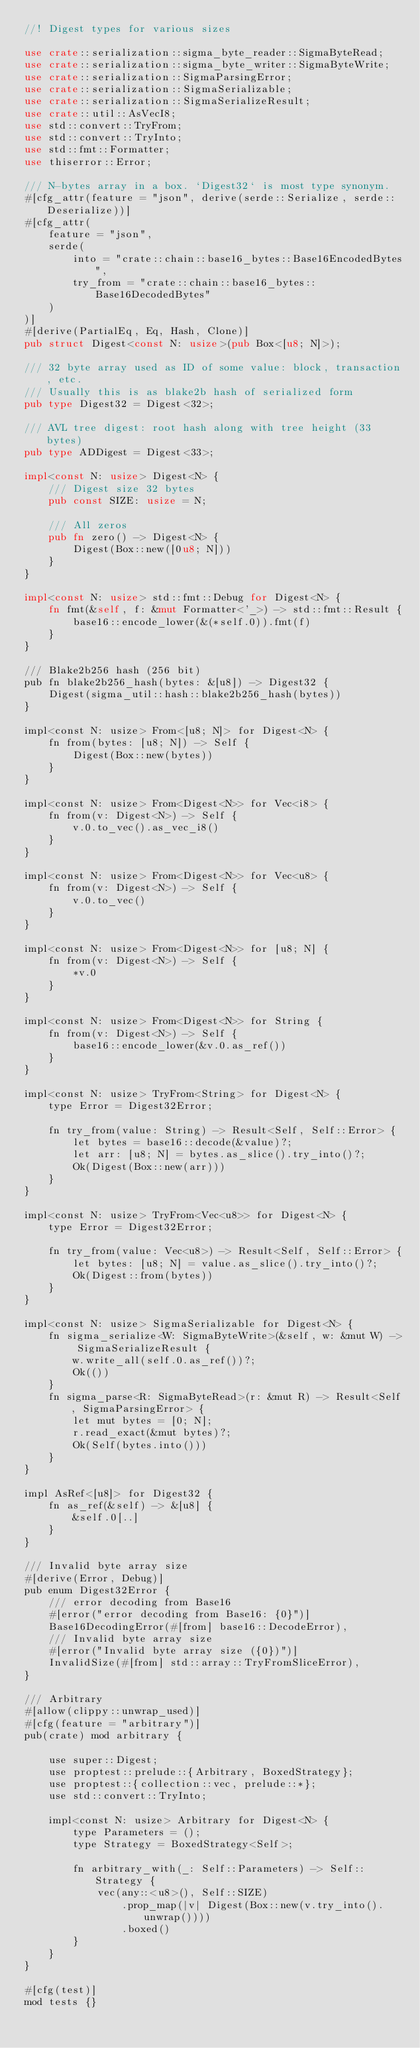Convert code to text. <code><loc_0><loc_0><loc_500><loc_500><_Rust_>//! Digest types for various sizes

use crate::serialization::sigma_byte_reader::SigmaByteRead;
use crate::serialization::sigma_byte_writer::SigmaByteWrite;
use crate::serialization::SigmaParsingError;
use crate::serialization::SigmaSerializable;
use crate::serialization::SigmaSerializeResult;
use crate::util::AsVecI8;
use std::convert::TryFrom;
use std::convert::TryInto;
use std::fmt::Formatter;
use thiserror::Error;

/// N-bytes array in a box. `Digest32` is most type synonym.
#[cfg_attr(feature = "json", derive(serde::Serialize, serde::Deserialize))]
#[cfg_attr(
    feature = "json",
    serde(
        into = "crate::chain::base16_bytes::Base16EncodedBytes",
        try_from = "crate::chain::base16_bytes::Base16DecodedBytes"
    )
)]
#[derive(PartialEq, Eq, Hash, Clone)]
pub struct Digest<const N: usize>(pub Box<[u8; N]>);

/// 32 byte array used as ID of some value: block, transaction, etc.
/// Usually this is as blake2b hash of serialized form
pub type Digest32 = Digest<32>;

/// AVL tree digest: root hash along with tree height (33 bytes)
pub type ADDigest = Digest<33>;

impl<const N: usize> Digest<N> {
    /// Digest size 32 bytes
    pub const SIZE: usize = N;

    /// All zeros
    pub fn zero() -> Digest<N> {
        Digest(Box::new([0u8; N]))
    }
}

impl<const N: usize> std::fmt::Debug for Digest<N> {
    fn fmt(&self, f: &mut Formatter<'_>) -> std::fmt::Result {
        base16::encode_lower(&(*self.0)).fmt(f)
    }
}

/// Blake2b256 hash (256 bit)
pub fn blake2b256_hash(bytes: &[u8]) -> Digest32 {
    Digest(sigma_util::hash::blake2b256_hash(bytes))
}

impl<const N: usize> From<[u8; N]> for Digest<N> {
    fn from(bytes: [u8; N]) -> Self {
        Digest(Box::new(bytes))
    }
}

impl<const N: usize> From<Digest<N>> for Vec<i8> {
    fn from(v: Digest<N>) -> Self {
        v.0.to_vec().as_vec_i8()
    }
}

impl<const N: usize> From<Digest<N>> for Vec<u8> {
    fn from(v: Digest<N>) -> Self {
        v.0.to_vec()
    }
}

impl<const N: usize> From<Digest<N>> for [u8; N] {
    fn from(v: Digest<N>) -> Self {
        *v.0
    }
}

impl<const N: usize> From<Digest<N>> for String {
    fn from(v: Digest<N>) -> Self {
        base16::encode_lower(&v.0.as_ref())
    }
}

impl<const N: usize> TryFrom<String> for Digest<N> {
    type Error = Digest32Error;

    fn try_from(value: String) -> Result<Self, Self::Error> {
        let bytes = base16::decode(&value)?;
        let arr: [u8; N] = bytes.as_slice().try_into()?;
        Ok(Digest(Box::new(arr)))
    }
}

impl<const N: usize> TryFrom<Vec<u8>> for Digest<N> {
    type Error = Digest32Error;

    fn try_from(value: Vec<u8>) -> Result<Self, Self::Error> {
        let bytes: [u8; N] = value.as_slice().try_into()?;
        Ok(Digest::from(bytes))
    }
}

impl<const N: usize> SigmaSerializable for Digest<N> {
    fn sigma_serialize<W: SigmaByteWrite>(&self, w: &mut W) -> SigmaSerializeResult {
        w.write_all(self.0.as_ref())?;
        Ok(())
    }
    fn sigma_parse<R: SigmaByteRead>(r: &mut R) -> Result<Self, SigmaParsingError> {
        let mut bytes = [0; N];
        r.read_exact(&mut bytes)?;
        Ok(Self(bytes.into()))
    }
}

impl AsRef<[u8]> for Digest32 {
    fn as_ref(&self) -> &[u8] {
        &self.0[..]
    }
}

/// Invalid byte array size
#[derive(Error, Debug)]
pub enum Digest32Error {
    /// error decoding from Base16
    #[error("error decoding from Base16: {0}")]
    Base16DecodingError(#[from] base16::DecodeError),
    /// Invalid byte array size
    #[error("Invalid byte array size ({0})")]
    InvalidSize(#[from] std::array::TryFromSliceError),
}

/// Arbitrary
#[allow(clippy::unwrap_used)]
#[cfg(feature = "arbitrary")]
pub(crate) mod arbitrary {

    use super::Digest;
    use proptest::prelude::{Arbitrary, BoxedStrategy};
    use proptest::{collection::vec, prelude::*};
    use std::convert::TryInto;

    impl<const N: usize> Arbitrary for Digest<N> {
        type Parameters = ();
        type Strategy = BoxedStrategy<Self>;

        fn arbitrary_with(_: Self::Parameters) -> Self::Strategy {
            vec(any::<u8>(), Self::SIZE)
                .prop_map(|v| Digest(Box::new(v.try_into().unwrap())))
                .boxed()
        }
    }
}

#[cfg(test)]
mod tests {}
</code> 